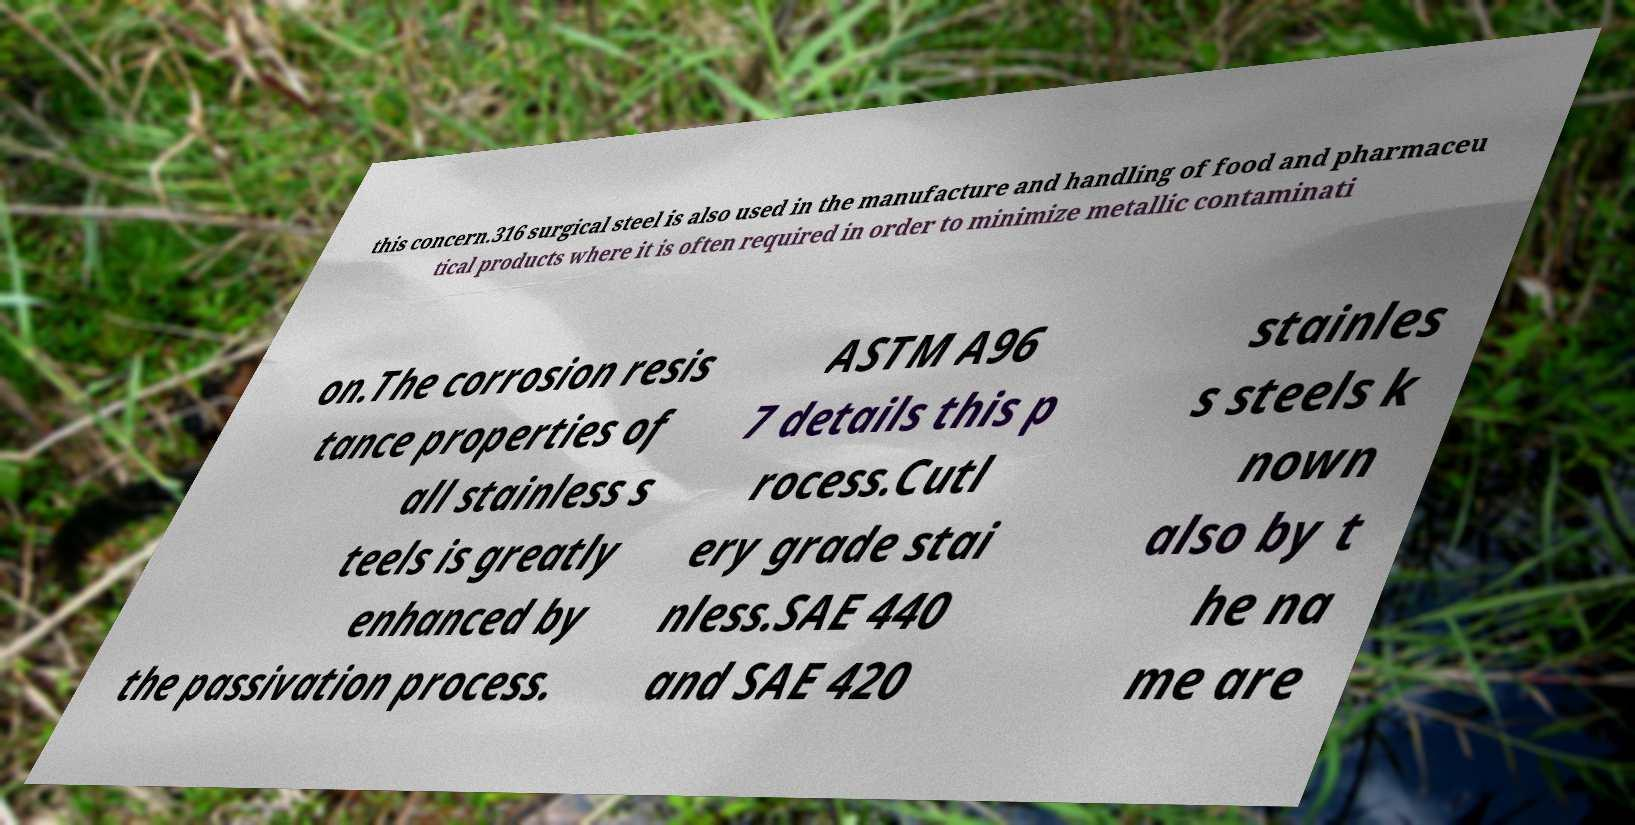Please read and relay the text visible in this image. What does it say? this concern.316 surgical steel is also used in the manufacture and handling of food and pharmaceu tical products where it is often required in order to minimize metallic contaminati on.The corrosion resis tance properties of all stainless s teels is greatly enhanced by the passivation process. ASTM A96 7 details this p rocess.Cutl ery grade stai nless.SAE 440 and SAE 420 stainles s steels k nown also by t he na me are 